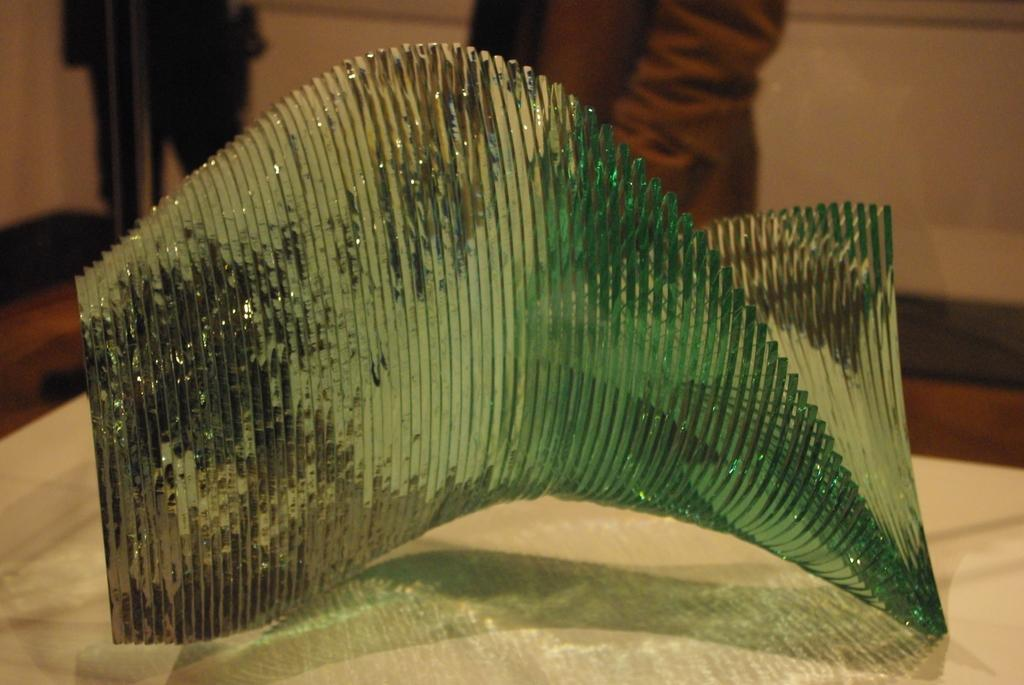What is the main object on the table in the image? There is a glass object on a table in the image. How many people are present in the image? There are two persons standing in the image. What can be seen in the background of the image? There is a wall visible in the image. Where is the nest located in the image? There is no nest present in the image. What type of lettuce can be seen growing on the wall in the image? There is no lettuce or any vegetation growing on the wall in the image. 